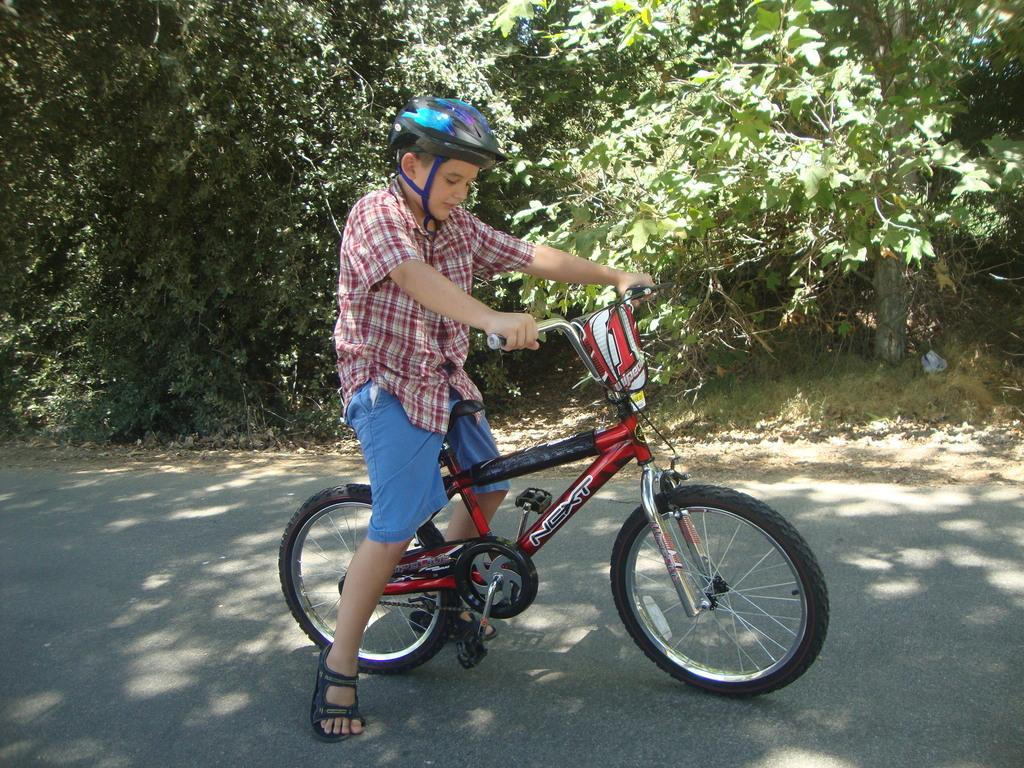Who is the main subject in the image? There is a boy in the image. What is the boy wearing on his head? The boy is wearing a helmet. What is the boy doing in the image? The boy is on a bicycle. What can be seen in the background of the image? There are trees in the background of the image. What type of dust can be seen on the boy's bicycle in the image? There is no dust visible on the boy's bicycle in the image. 